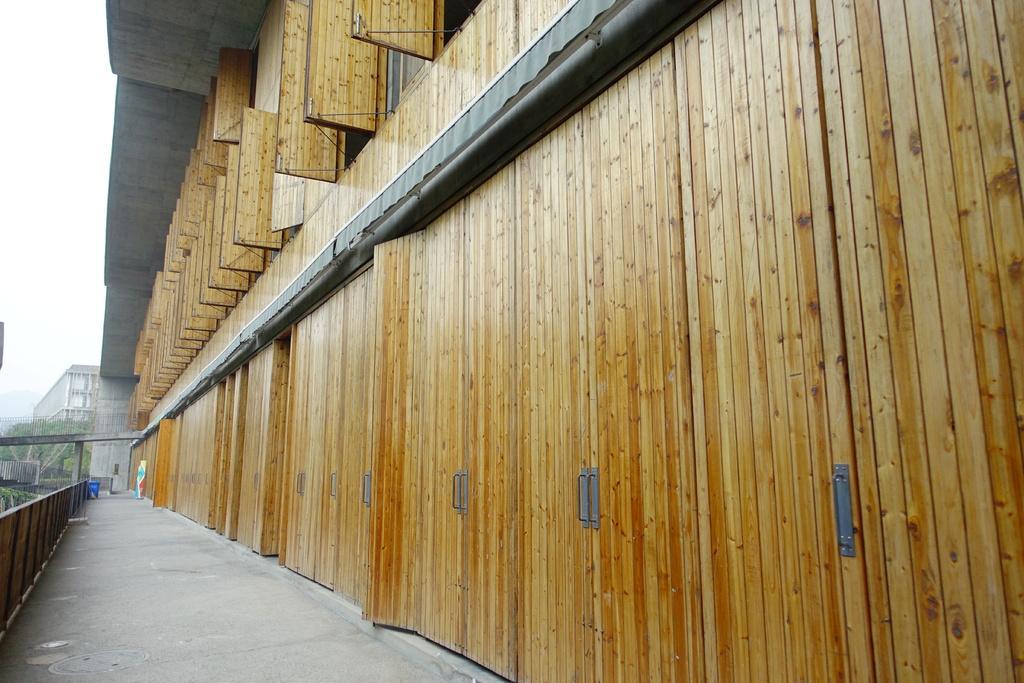How would you summarize this image in a sentence or two? In this image we can see the corridor of a building, grills, trash bin, trees and sky. 